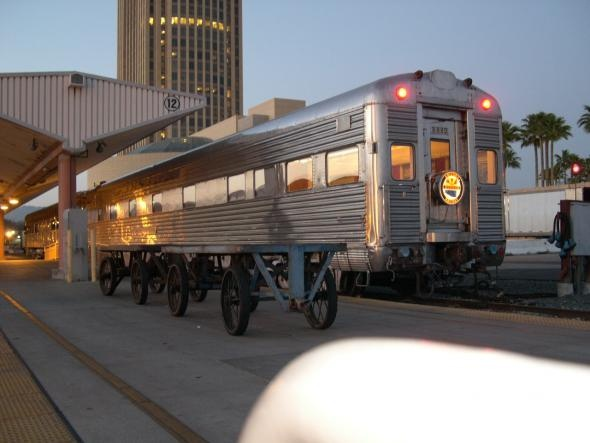Describe the objects in this image and their specific colors. I can see train in darkgray, gray, black, and maroon tones and traffic light in darkgray, maroon, brown, salmon, and black tones in this image. 